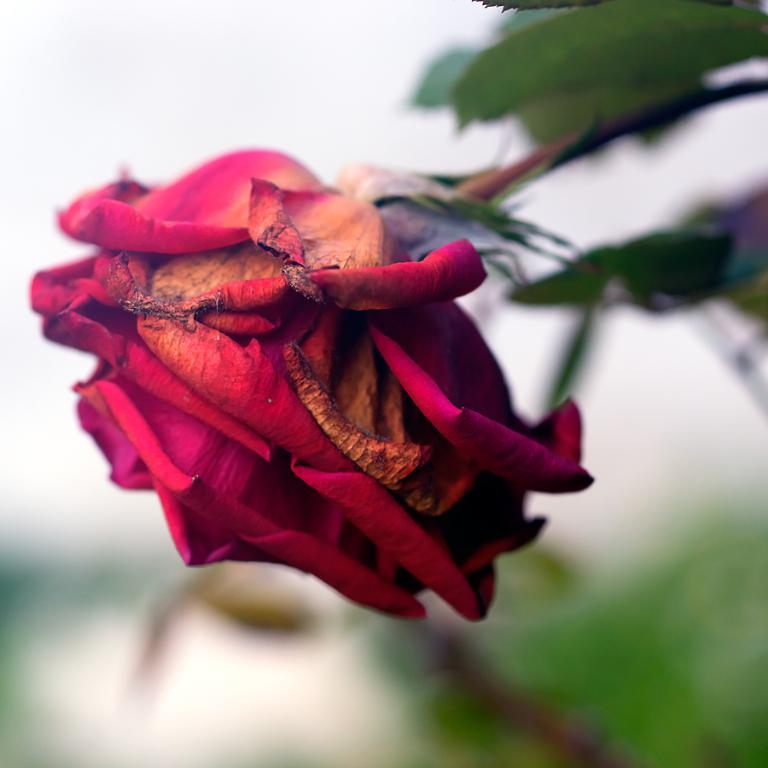What type of flower is in the image? There is a rose flower in the image. How is the rose flower positioned in the image? The rose flower is hanging on a plant. Where is the bulb located in the image? There is no bulb present in the image. What type of kitten can be seen playing with the rose flower in the image? There is no kitten present in the image, and therefore no such activity can be observed. 